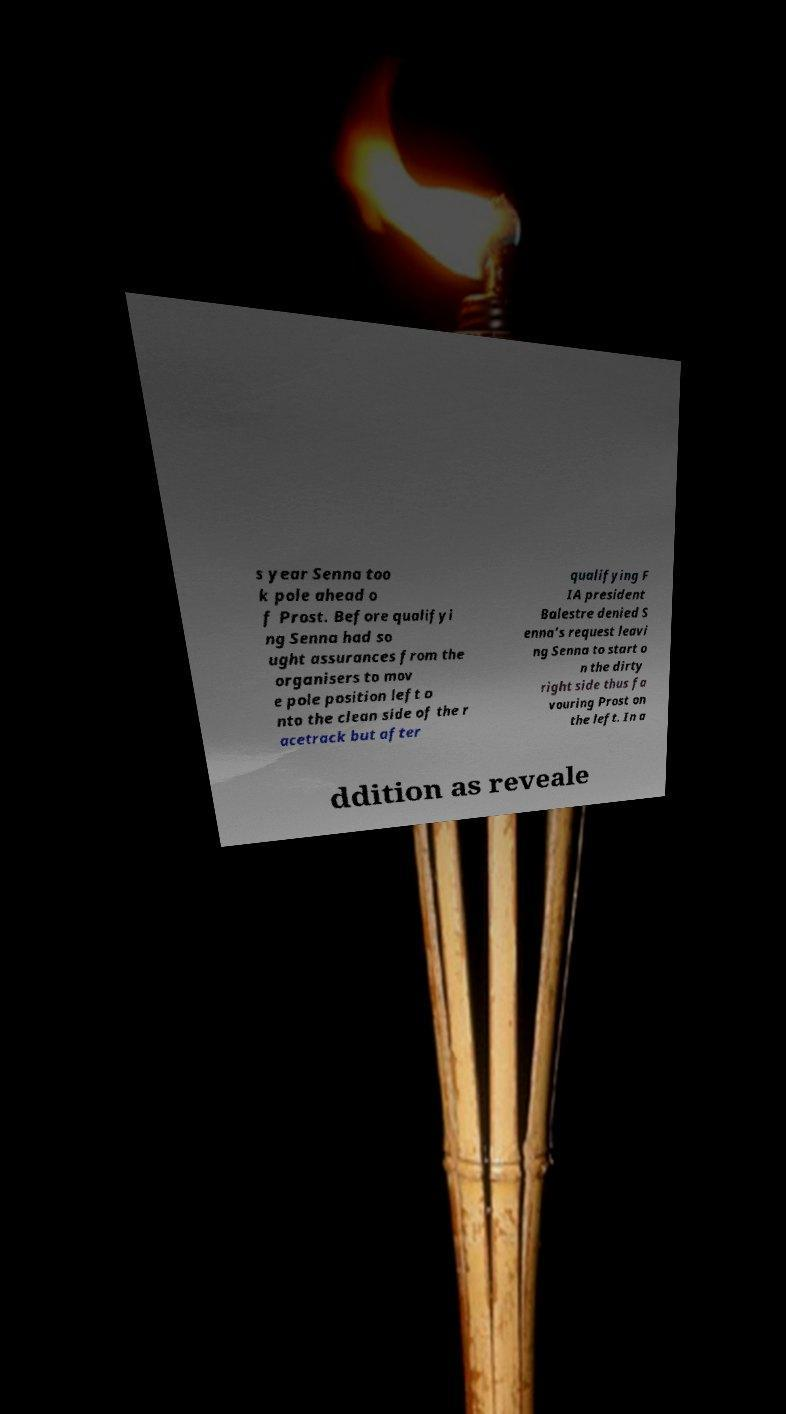For documentation purposes, I need the text within this image transcribed. Could you provide that? s year Senna too k pole ahead o f Prost. Before qualifyi ng Senna had so ught assurances from the organisers to mov e pole position left o nto the clean side of the r acetrack but after qualifying F IA president Balestre denied S enna's request leavi ng Senna to start o n the dirty right side thus fa vouring Prost on the left. In a ddition as reveale 